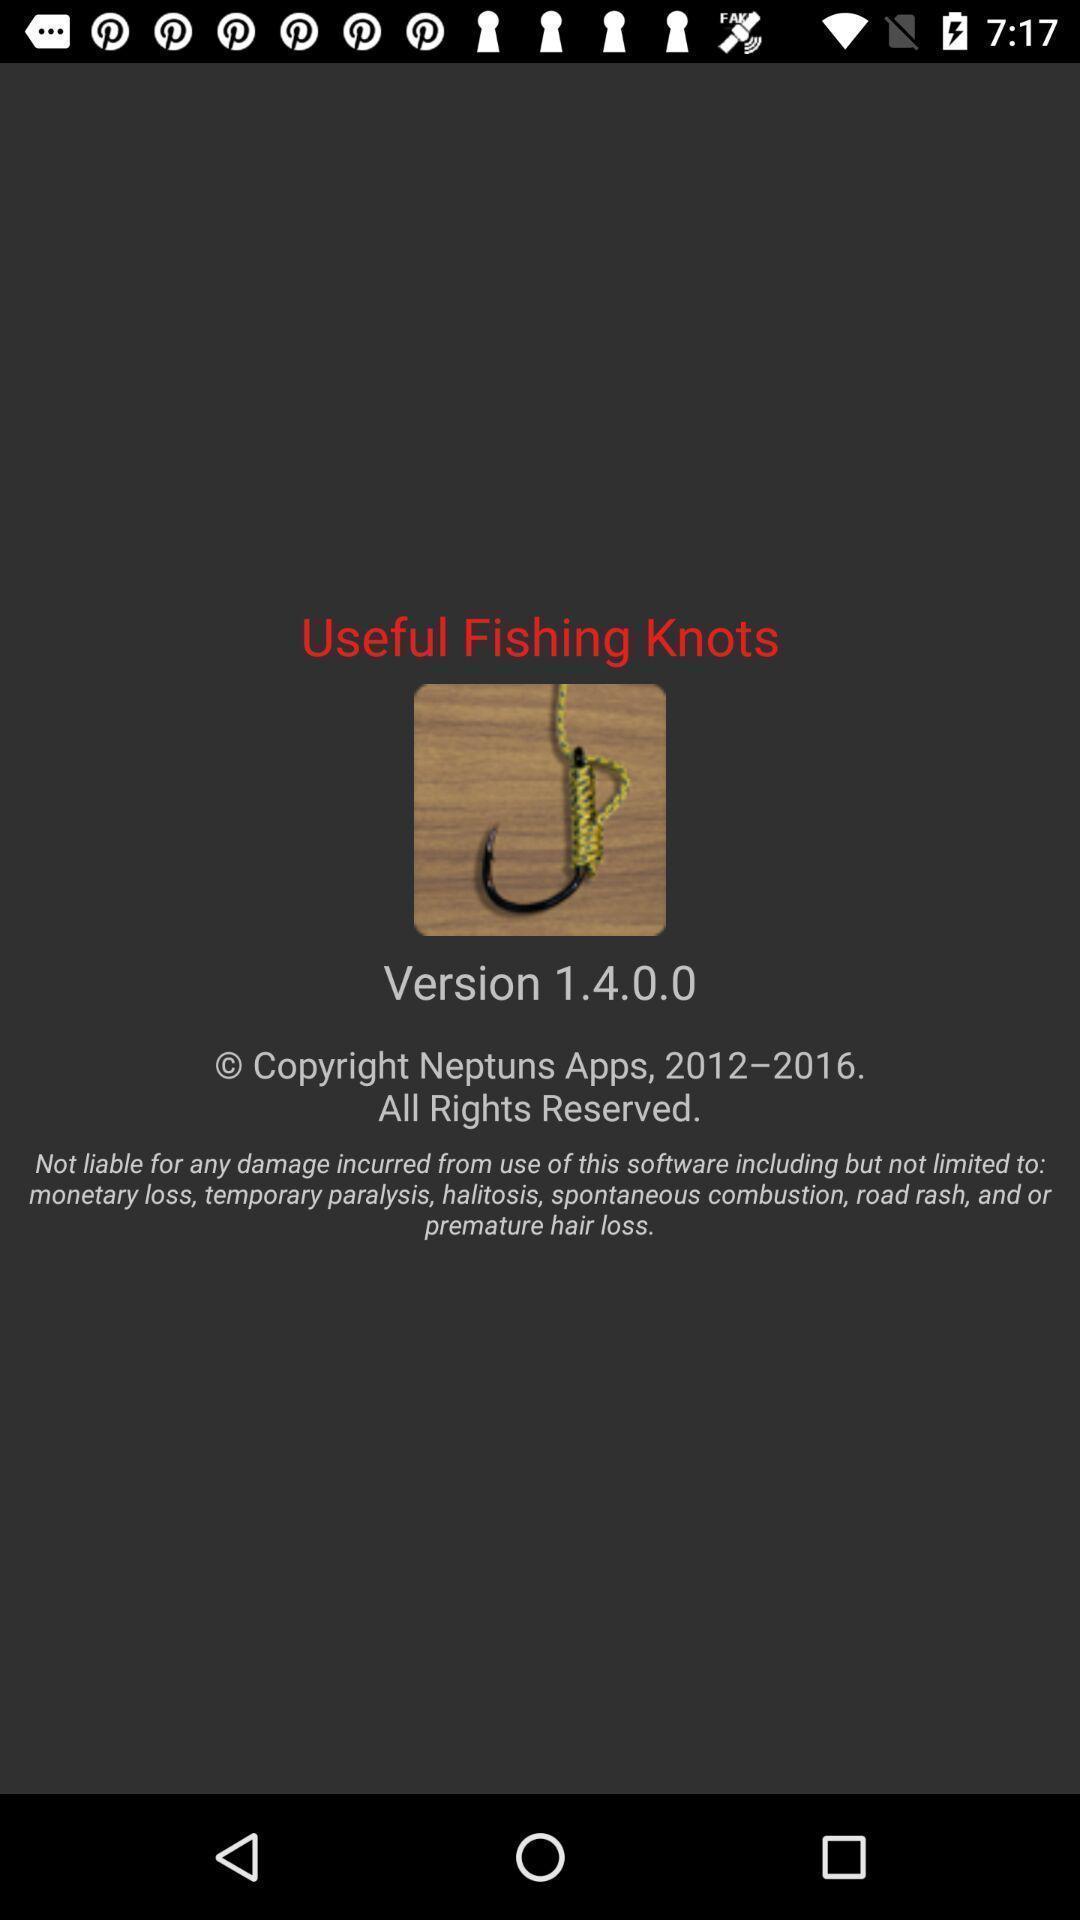Describe the visual elements of this screenshot. Page displaying the version. 